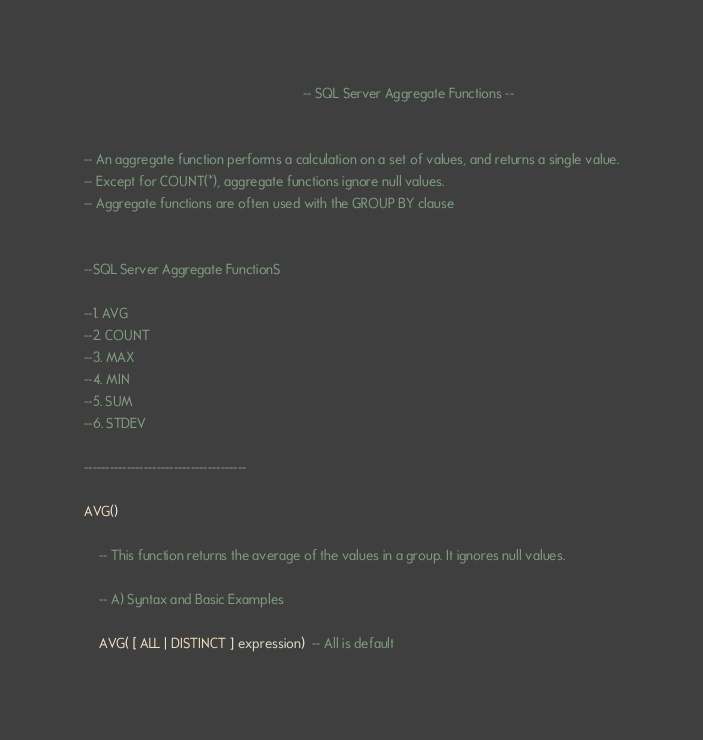Convert code to text. <code><loc_0><loc_0><loc_500><loc_500><_SQL_>															-- SQL Server Aggregate Functions --


-- An aggregate function performs a calculation on a set of values, and returns a single value.
-- Except for COUNT(*), aggregate functions ignore null values.
-- Aggregate functions are often used with the GROUP BY clause


--SQL Server Aggregate FunctionS

--1. AVG
--2. COUNT
--3. MAX
--4. MIN
--5. SUM
--6. STDEV

--------------------------------------

AVG()

	-- This function returns the average of the values in a group. It ignores null values.

	-- A) Syntax and Basic Examples

	AVG( [ ALL | DISTINCT ] expression)  -- All is default
</code> 